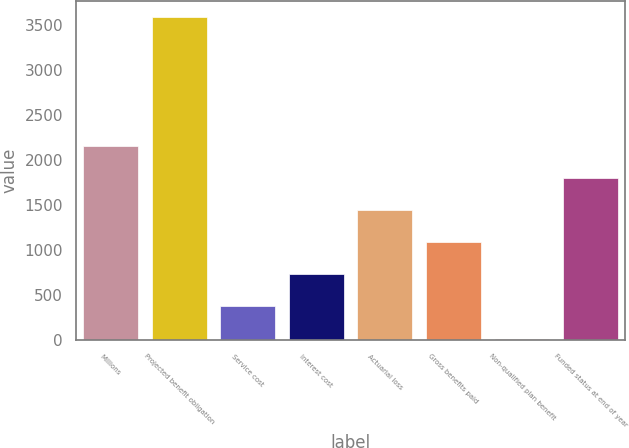<chart> <loc_0><loc_0><loc_500><loc_500><bar_chart><fcel>Millions<fcel>Projected benefit obligation<fcel>Service cost<fcel>Interest cost<fcel>Actuarial loss<fcel>Gross benefits paid<fcel>Non-qualified plan benefit<fcel>Funded status at end of year<nl><fcel>2160.6<fcel>3591<fcel>372.6<fcel>730.2<fcel>1445.4<fcel>1087.8<fcel>15<fcel>1803<nl></chart> 